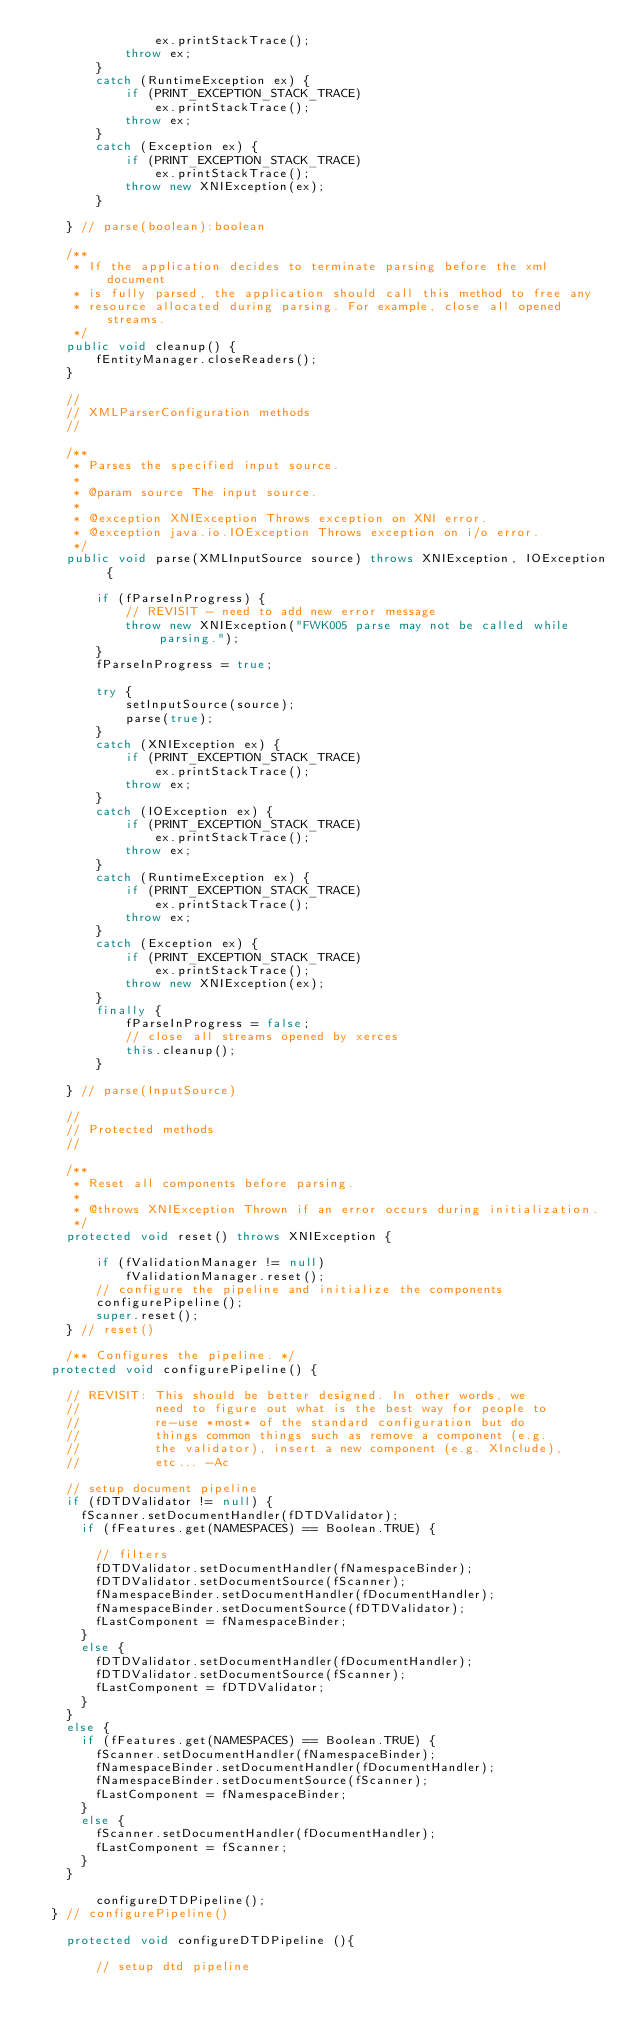<code> <loc_0><loc_0><loc_500><loc_500><_Java_>                ex.printStackTrace();
            throw ex;
        } 
        catch (RuntimeException ex) {
            if (PRINT_EXCEPTION_STACK_TRACE)
                ex.printStackTrace();
            throw ex;
        }
        catch (Exception ex) {
            if (PRINT_EXCEPTION_STACK_TRACE)
                ex.printStackTrace();
            throw new XNIException(ex);
        }

    } // parse(boolean):boolean

    /**
     * If the application decides to terminate parsing before the xml document
     * is fully parsed, the application should call this method to free any
     * resource allocated during parsing. For example, close all opened streams.
     */
    public void cleanup() {
        fEntityManager.closeReaders();
    }
    
    //
    // XMLParserConfiguration methods
    //

    /**
     * Parses the specified input source.
     *
     * @param source The input source.
     *
     * @exception XNIException Throws exception on XNI error.
     * @exception java.io.IOException Throws exception on i/o error.
     */
    public void parse(XMLInputSource source) throws XNIException, IOException {

        if (fParseInProgress) {
            // REVISIT - need to add new error message
            throw new XNIException("FWK005 parse may not be called while parsing.");
        }
        fParseInProgress = true;

        try {
            setInputSource(source);
            parse(true);
        } 
        catch (XNIException ex) {
            if (PRINT_EXCEPTION_STACK_TRACE)
                ex.printStackTrace();
            throw ex;
        } 
        catch (IOException ex) {
            if (PRINT_EXCEPTION_STACK_TRACE)
                ex.printStackTrace();
            throw ex;
        }
        catch (RuntimeException ex) {
            if (PRINT_EXCEPTION_STACK_TRACE)
                ex.printStackTrace();
            throw ex;
        }              
        catch (Exception ex) {
            if (PRINT_EXCEPTION_STACK_TRACE)
                ex.printStackTrace();
            throw new XNIException(ex);
        }
        finally {
            fParseInProgress = false;
            // close all streams opened by xerces
            this.cleanup();
        }

    } // parse(InputSource)

    //
    // Protected methods
    //
    
    /** 
     * Reset all components before parsing. 
     *
     * @throws XNIException Thrown if an error occurs during initialization.
     */
    protected void reset() throws XNIException {

        if (fValidationManager != null)
            fValidationManager.reset();
        // configure the pipeline and initialize the components
        configurePipeline();
        super.reset();
    } // reset()

    /** Configures the pipeline. */
	protected void configurePipeline() {

		// REVISIT: This should be better designed. In other words, we
		//          need to figure out what is the best way for people to
		//          re-use *most* of the standard configuration but do 
		//          things common things such as remove a component (e.g.
		//          the validator), insert a new component (e.g. XInclude), 
		//          etc... -Ac

		// setup document pipeline
		if (fDTDValidator != null) {
			fScanner.setDocumentHandler(fDTDValidator);
			if (fFeatures.get(NAMESPACES) == Boolean.TRUE) {

				// filters
				fDTDValidator.setDocumentHandler(fNamespaceBinder);
				fDTDValidator.setDocumentSource(fScanner);
				fNamespaceBinder.setDocumentHandler(fDocumentHandler);
				fNamespaceBinder.setDocumentSource(fDTDValidator);
				fLastComponent = fNamespaceBinder;
			}
			else {
				fDTDValidator.setDocumentHandler(fDocumentHandler);
				fDTDValidator.setDocumentSource(fScanner);
				fLastComponent = fDTDValidator;
			}
		}
		else {
			if (fFeatures.get(NAMESPACES) == Boolean.TRUE) {
				fScanner.setDocumentHandler(fNamespaceBinder);
				fNamespaceBinder.setDocumentHandler(fDocumentHandler);
				fNamespaceBinder.setDocumentSource(fScanner);
				fLastComponent = fNamespaceBinder;
			}
			else {
				fScanner.setDocumentHandler(fDocumentHandler);
				fLastComponent = fScanner;
			}
		}
        
        configureDTDPipeline();
	} // configurePipeline()
    
    protected void configureDTDPipeline (){
        
        // setup dtd pipeline</code> 